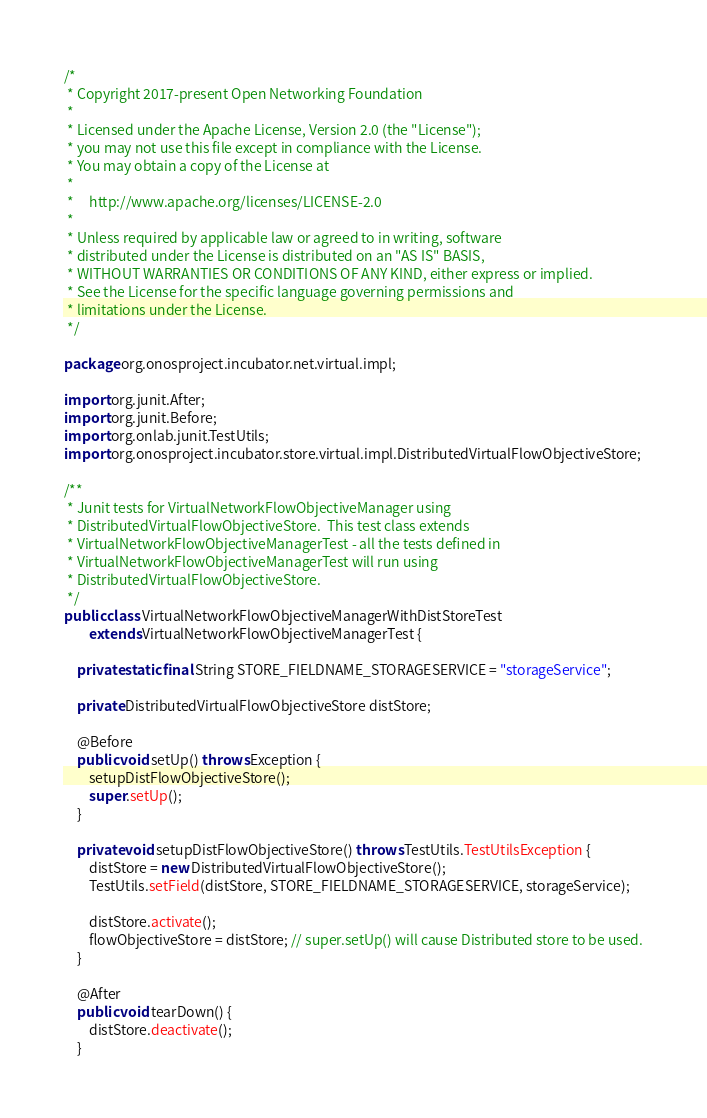<code> <loc_0><loc_0><loc_500><loc_500><_Java_>/*
 * Copyright 2017-present Open Networking Foundation
 *
 * Licensed under the Apache License, Version 2.0 (the "License");
 * you may not use this file except in compliance with the License.
 * You may obtain a copy of the License at
 *
 *     http://www.apache.org/licenses/LICENSE-2.0
 *
 * Unless required by applicable law or agreed to in writing, software
 * distributed under the License is distributed on an "AS IS" BASIS,
 * WITHOUT WARRANTIES OR CONDITIONS OF ANY KIND, either express or implied.
 * See the License for the specific language governing permissions and
 * limitations under the License.
 */

package org.onosproject.incubator.net.virtual.impl;

import org.junit.After;
import org.junit.Before;
import org.onlab.junit.TestUtils;
import org.onosproject.incubator.store.virtual.impl.DistributedVirtualFlowObjectiveStore;

/**
 * Junit tests for VirtualNetworkFlowObjectiveManager using
 * DistributedVirtualFlowObjectiveStore.  This test class extends
 * VirtualNetworkFlowObjectiveManagerTest - all the tests defined in
 * VirtualNetworkFlowObjectiveManagerTest will run using
 * DistributedVirtualFlowObjectiveStore.
 */
public class VirtualNetworkFlowObjectiveManagerWithDistStoreTest
        extends VirtualNetworkFlowObjectiveManagerTest {

    private static final String STORE_FIELDNAME_STORAGESERVICE = "storageService";

    private DistributedVirtualFlowObjectiveStore distStore;

    @Before
    public void setUp() throws Exception {
        setupDistFlowObjectiveStore();
        super.setUp();
    }

    private void setupDistFlowObjectiveStore() throws TestUtils.TestUtilsException {
        distStore = new DistributedVirtualFlowObjectiveStore();
        TestUtils.setField(distStore, STORE_FIELDNAME_STORAGESERVICE, storageService);

        distStore.activate();
        flowObjectiveStore = distStore; // super.setUp() will cause Distributed store to be used.
    }

    @After
    public void tearDown() {
        distStore.deactivate();
    }</code> 